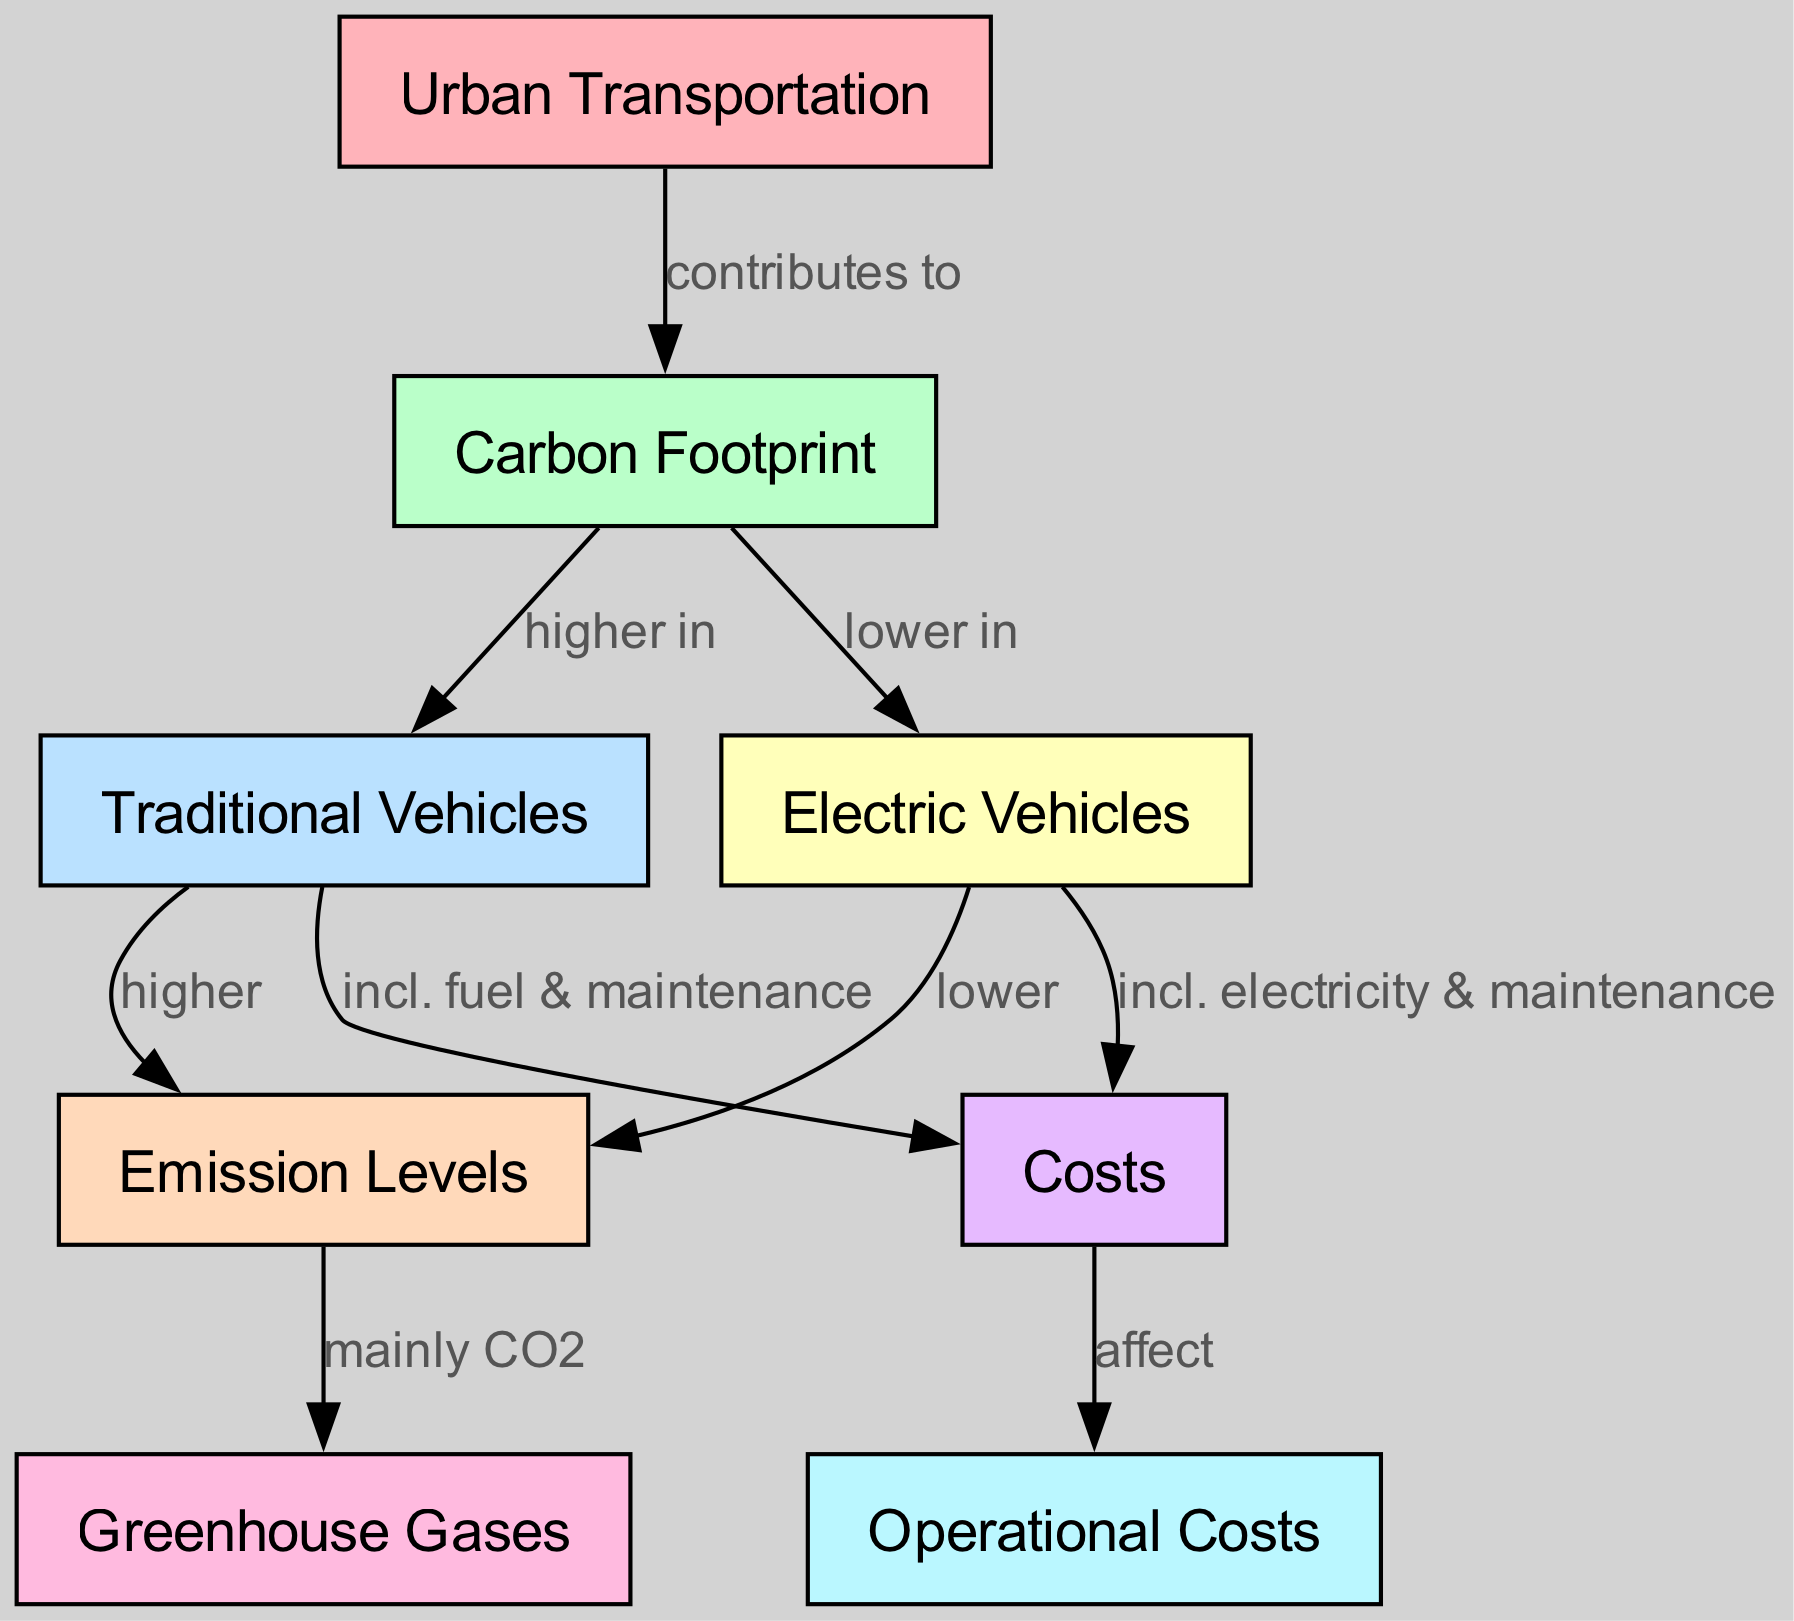What is the main contribution of urban transportation? The diagram indicates that urban transportation contributes to carbon footprint. This is seen in the edge from "Urban Transportation" to "Carbon Footprint" indicating their relationship.
Answer: carbon footprint Which vehicle type has higher emission levels? The diagram shows that traditional vehicles have higher emission levels as indicated by the edge from "Traditional Vehicles" to "Emission Levels".
Answer: Traditional Vehicles What gas is mainly emitted by traditional vehicles? The diagram specifies that traditional vehicles mainly emit CO2, as detailed in the edge connecting "Emission Levels" to "Greenhouse Gases".
Answer: CO2 What do electric vehicles have lower in comparison to traditional vehicles? The diagram indicates that electric vehicles have lower emission levels compared to traditional vehicles as shown in the edge from "Carbon Footprint" to "Electric Vehicles".
Answer: emission levels How do operational costs relate to traditional vehicles? The diagram states that the costs related to traditional vehicles include fuel and maintenance, as per the edge from "Traditional Vehicles" to "Costs".
Answer: fuel and maintenance Considering the diagram, what is one aspect included in the costs for electric vehicles? The edge from "Electric Vehicles" to "Costs" mentions that the costs include electricity and maintenance, directly answering the question about costs associated with electric vehicles.
Answer: electricity and maintenance How many nodes are present in this diagram? This can be counted directly from the diagram where the nodes represent different concepts, totaling eight nodes.
Answer: eight Which vehicle type is associated with lower carbon footprint? The diagram shows that electric vehicles are associated with a lower carbon footprint due to the relationship expressed in the edge from "Carbon Footprint" to "Electric Vehicles".
Answer: Electric Vehicles What kind of costs affect operational costs? According to the diagram, costs affecting operational costs include fuel, electricity, and maintenance as illustrated through connections to both traditional and electric vehicles.
Answer: fuel, electricity, and maintenance 